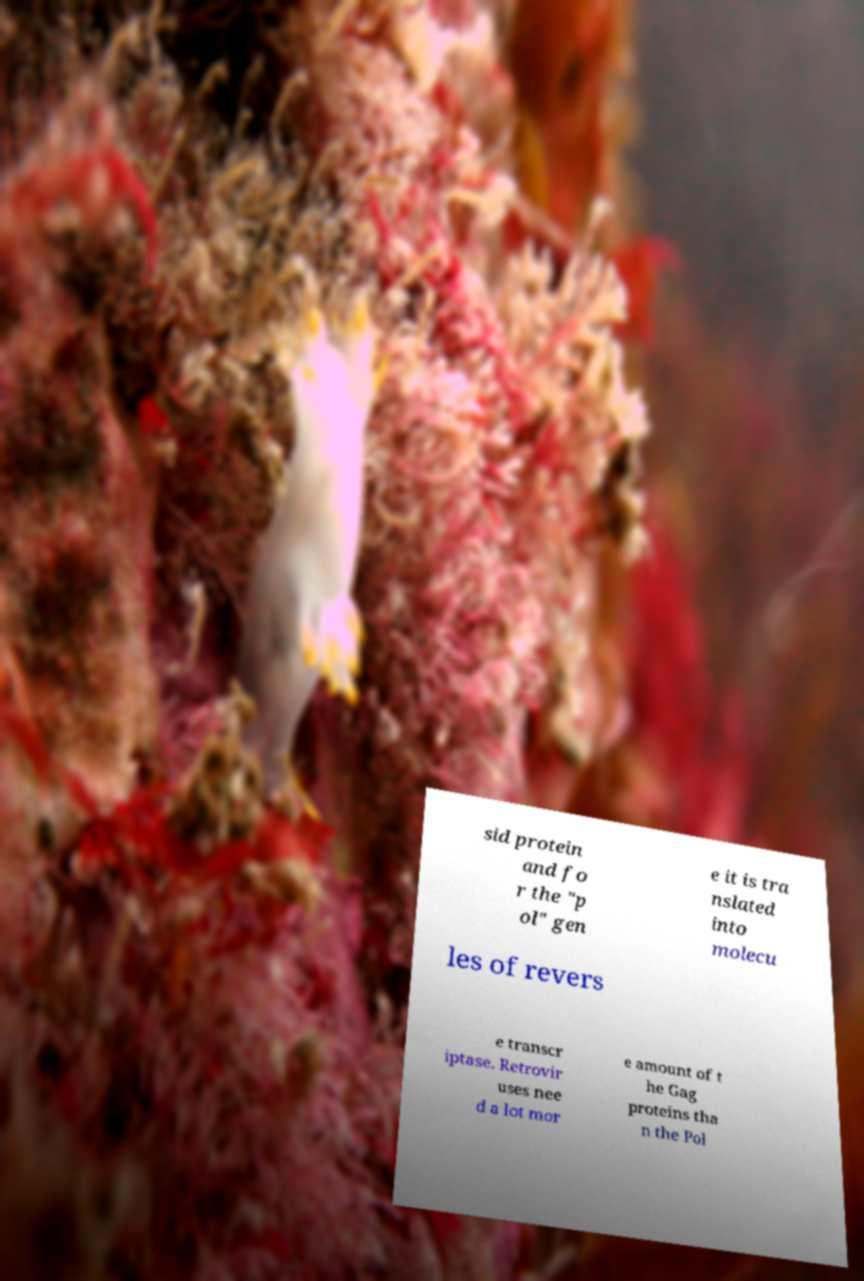Please identify and transcribe the text found in this image. sid protein and fo r the "p ol" gen e it is tra nslated into molecu les of revers e transcr iptase. Retrovir uses nee d a lot mor e amount of t he Gag proteins tha n the Pol 